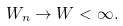<formula> <loc_0><loc_0><loc_500><loc_500>W _ { n } \rightarrow W < \infty .</formula> 